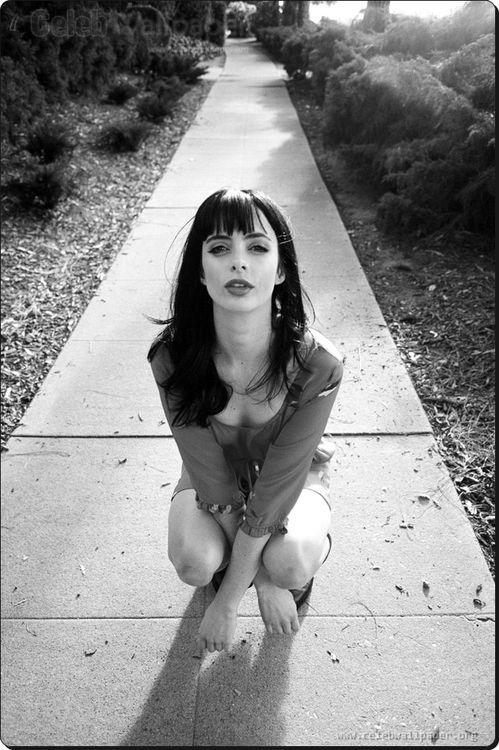Imagine this image is the cover of a mystery novel. What would the title and plot be? Title: 'Shadows of the Past'
Plot: In 'Shadows of the Past,' we follow the story of Eliza, a woman haunted by her past as she kneels on the sidewalk, a symbolic moment of her breaking point. The novel delves into her journey filled with secrets, as she unravels the mysteries surrounding her family's dark history. Eliza's intense gaze captures the grit and determination she needs to uncover the truth, battling inner demons and external threats, all while trying to find redemption. 